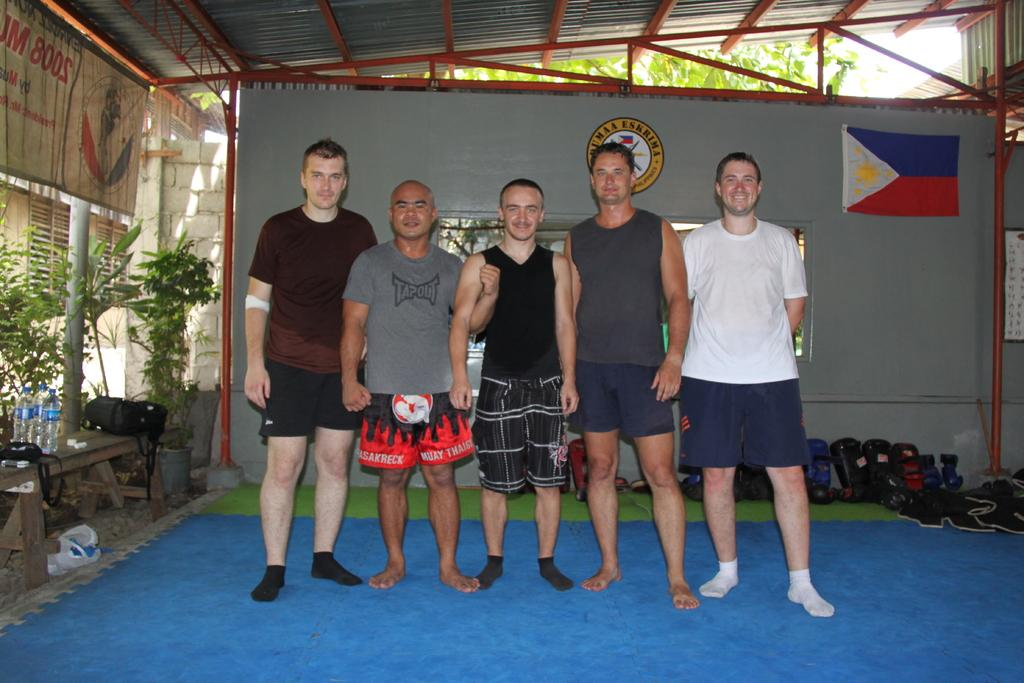<image>
Give a short and clear explanation of the subsequent image. Five men posing and one has a Tapout shirt on 